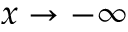Convert formula to latex. <formula><loc_0><loc_0><loc_500><loc_500>x \to - \infty</formula> 